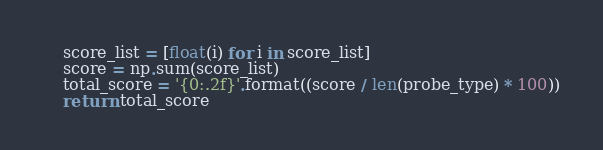Convert code to text. <code><loc_0><loc_0><loc_500><loc_500><_Python_>    score_list = [float(i) for i in score_list]
    score = np.sum(score_list)
    total_score = '{0:.2f}'.format((score / len(probe_type) * 100))
    return total_score
</code> 